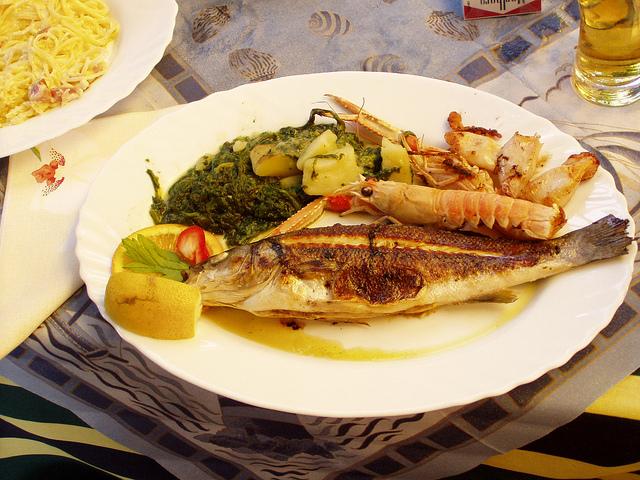Do you see a lime slice?
Keep it brief. No. Is the American heart association likely to give this dish a thumbs up?
Short answer required. Yes. How is the fish cooked?
Keep it brief. Grilled. 